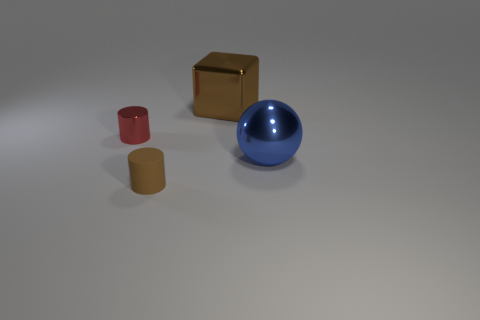Is the large metallic block the same color as the tiny matte object?
Offer a very short reply. Yes. What material is the big object on the right side of the big brown cube?
Provide a short and direct response. Metal. Is the size of the blue thing the same as the red cylinder?
Offer a very short reply. No. Are there more big blue metallic balls that are right of the brown matte cylinder than metal spheres?
Give a very brief answer. No. What is the size of the red cylinder that is made of the same material as the large brown thing?
Give a very brief answer. Small. Are there any big brown metal objects right of the large brown metal block?
Offer a terse response. No. Is the shape of the tiny brown thing the same as the large brown thing?
Give a very brief answer. No. What is the size of the cylinder in front of the big thing that is in front of the big object that is to the left of the ball?
Give a very brief answer. Small. What is the material of the large brown thing?
Provide a short and direct response. Metal. What is the size of the cylinder that is the same color as the metallic cube?
Ensure brevity in your answer.  Small. 